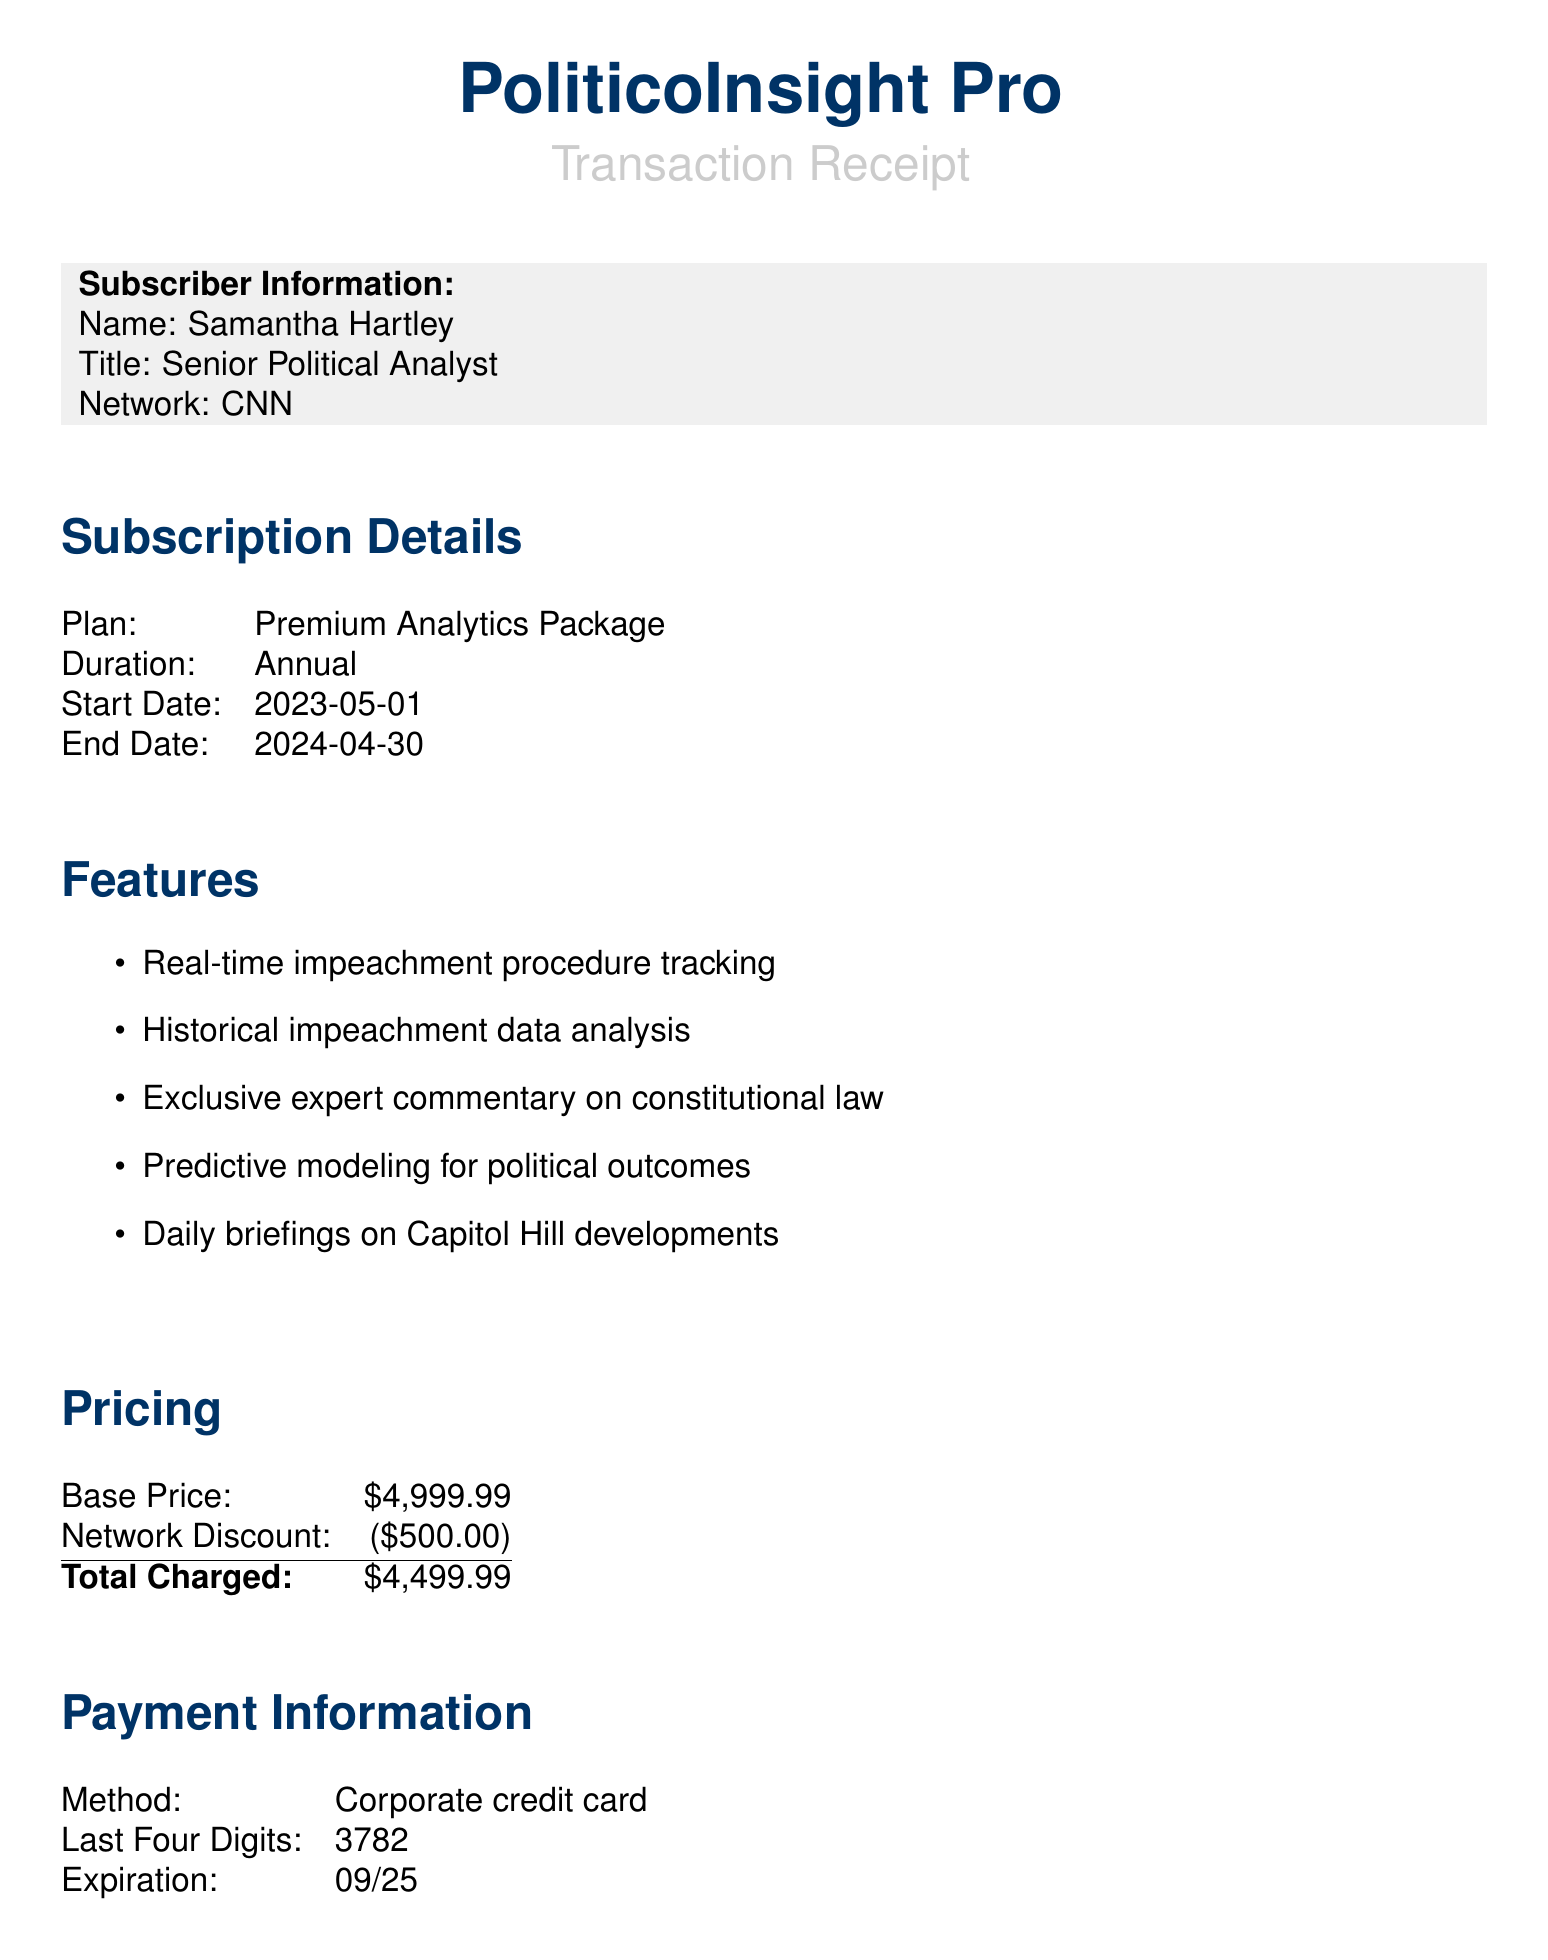What is the name of the service? The name of the service is clearly stated in the document header as "PoliticoInsight Pro."
Answer: PoliticoInsight Pro Who is the subscriber? The subscriber's name is mentioned in the document under Subscriber Information.
Answer: Samantha Hartley What is the subscription plan? The subscription plan is listed in the Subscription Details section of the document.
Answer: Premium Analytics Package When does the subscription end? The end date of the subscription is specified in the Subscription Details section.
Answer: 2024-04-30 What is the total charged amount? The total charged amount is found in the Pricing section of the document.
Answer: $4,499.99 What additional benefit involves strategy sessions? The benefit mentioning strategy sessions is described in the Additional Benefits section of the document.
Answer: Quarterly strategy sessions with former impeachment managers Who is the dedicated analyst for customer support? The dedicated analyst's name is provided in the Customer Support section of the document.
Answer: Marcus Chen What is the expiration date of the payment method? The expiration date for the payment method is found in the Payment Information section.
Answer: 09/25 What feature focuses on real-time updates? The feature focusing on real-time updates is outlined in the Features section of the document.
Answer: Real-time impeachment procedure tracking 